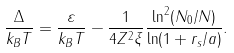Convert formula to latex. <formula><loc_0><loc_0><loc_500><loc_500>\frac { \Delta } { k _ { B } T } = \frac { \varepsilon } { k _ { B } T } - \frac { 1 } { 4 Z ^ { 2 } \xi } \frac { \ln ^ { 2 } ( N _ { 0 } / N ) } { \ln ( 1 + r _ { s } / a ) } .</formula> 